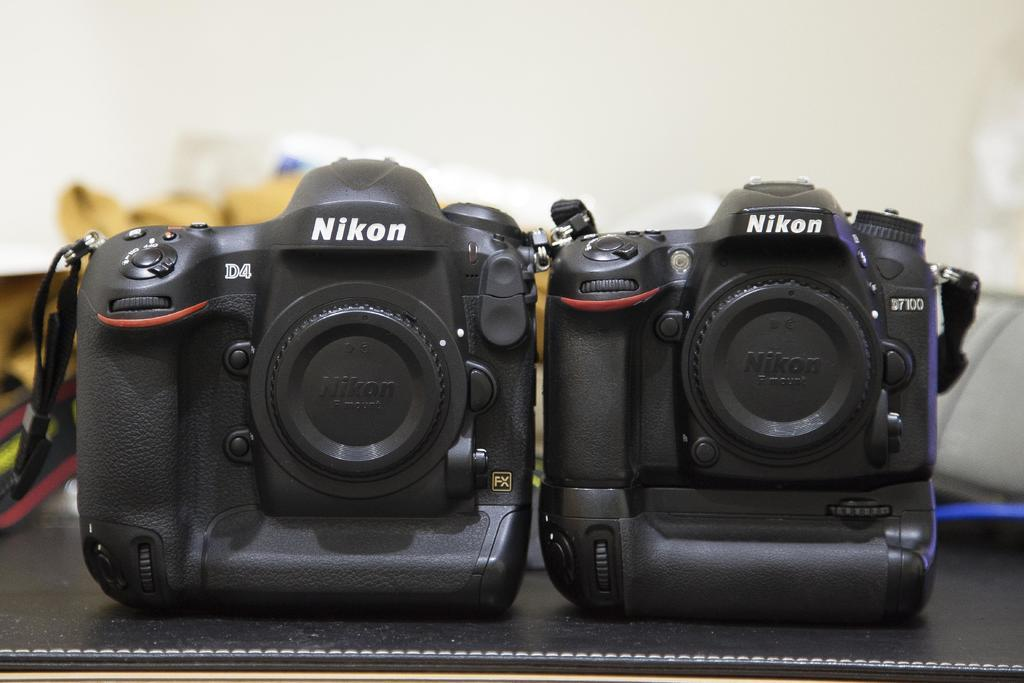What objects are present in the image? There are cameras in the image. Can you describe the background of the image? The background of the image is blurred. What type of chin can be seen on the cameras in the image? There is no chin present on the cameras in the image, as cameras do not have chins. What is the purpose of the cameras in the image, and how does it relate to copying or fuel? The purpose of the cameras in the image is not specified, and they have no direct relation to copying or fuel. 